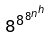<formula> <loc_0><loc_0><loc_500><loc_500>8 ^ { 8 ^ { 8 ^ { n ^ { h } } } }</formula> 